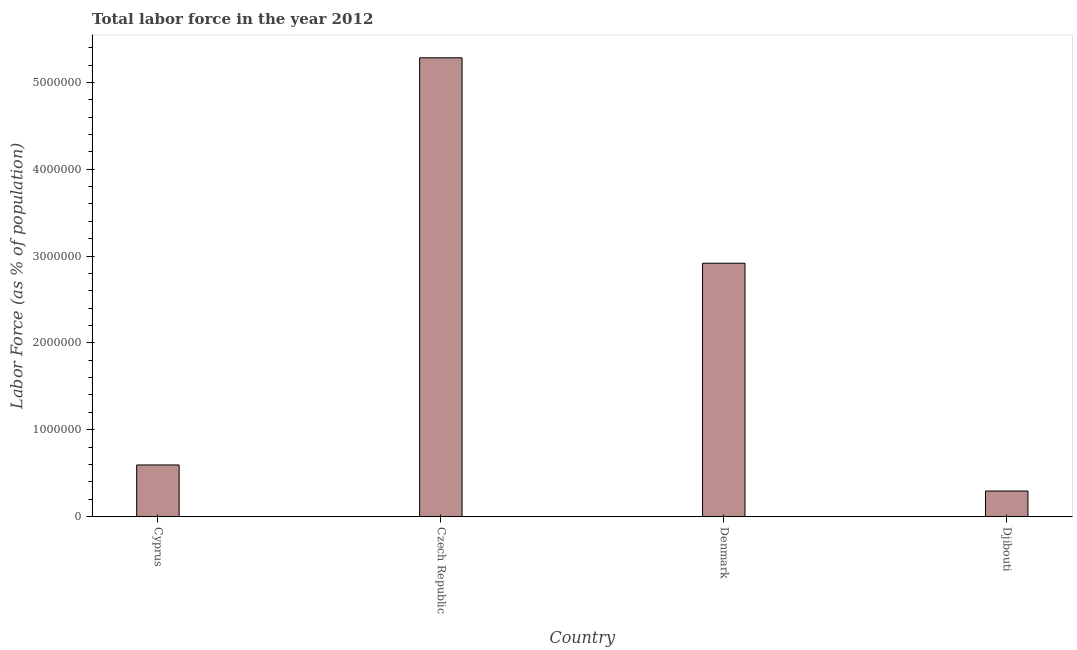Does the graph contain any zero values?
Offer a terse response. No. What is the title of the graph?
Give a very brief answer. Total labor force in the year 2012. What is the label or title of the X-axis?
Make the answer very short. Country. What is the label or title of the Y-axis?
Give a very brief answer. Labor Force (as % of population). What is the total labor force in Cyprus?
Offer a terse response. 5.94e+05. Across all countries, what is the maximum total labor force?
Provide a short and direct response. 5.28e+06. Across all countries, what is the minimum total labor force?
Offer a terse response. 2.93e+05. In which country was the total labor force maximum?
Offer a very short reply. Czech Republic. In which country was the total labor force minimum?
Ensure brevity in your answer.  Djibouti. What is the sum of the total labor force?
Your answer should be very brief. 9.09e+06. What is the difference between the total labor force in Czech Republic and Djibouti?
Keep it short and to the point. 4.99e+06. What is the average total labor force per country?
Provide a short and direct response. 2.27e+06. What is the median total labor force?
Offer a very short reply. 1.76e+06. What is the ratio of the total labor force in Cyprus to that in Djibouti?
Make the answer very short. 2.02. Is the total labor force in Czech Republic less than that in Djibouti?
Make the answer very short. No. What is the difference between the highest and the second highest total labor force?
Offer a terse response. 2.37e+06. What is the difference between the highest and the lowest total labor force?
Keep it short and to the point. 4.99e+06. In how many countries, is the total labor force greater than the average total labor force taken over all countries?
Ensure brevity in your answer.  2. How many bars are there?
Make the answer very short. 4. What is the difference between two consecutive major ticks on the Y-axis?
Your response must be concise. 1.00e+06. What is the Labor Force (as % of population) of Cyprus?
Offer a very short reply. 5.94e+05. What is the Labor Force (as % of population) of Czech Republic?
Keep it short and to the point. 5.28e+06. What is the Labor Force (as % of population) of Denmark?
Provide a succinct answer. 2.92e+06. What is the Labor Force (as % of population) of Djibouti?
Your answer should be compact. 2.93e+05. What is the difference between the Labor Force (as % of population) in Cyprus and Czech Republic?
Ensure brevity in your answer.  -4.69e+06. What is the difference between the Labor Force (as % of population) in Cyprus and Denmark?
Keep it short and to the point. -2.32e+06. What is the difference between the Labor Force (as % of population) in Cyprus and Djibouti?
Your response must be concise. 3.00e+05. What is the difference between the Labor Force (as % of population) in Czech Republic and Denmark?
Your answer should be very brief. 2.37e+06. What is the difference between the Labor Force (as % of population) in Czech Republic and Djibouti?
Make the answer very short. 4.99e+06. What is the difference between the Labor Force (as % of population) in Denmark and Djibouti?
Keep it short and to the point. 2.62e+06. What is the ratio of the Labor Force (as % of population) in Cyprus to that in Czech Republic?
Offer a very short reply. 0.11. What is the ratio of the Labor Force (as % of population) in Cyprus to that in Denmark?
Give a very brief answer. 0.2. What is the ratio of the Labor Force (as % of population) in Cyprus to that in Djibouti?
Keep it short and to the point. 2.02. What is the ratio of the Labor Force (as % of population) in Czech Republic to that in Denmark?
Keep it short and to the point. 1.81. What is the ratio of the Labor Force (as % of population) in Czech Republic to that in Djibouti?
Ensure brevity in your answer.  18.01. What is the ratio of the Labor Force (as % of population) in Denmark to that in Djibouti?
Provide a short and direct response. 9.95. 